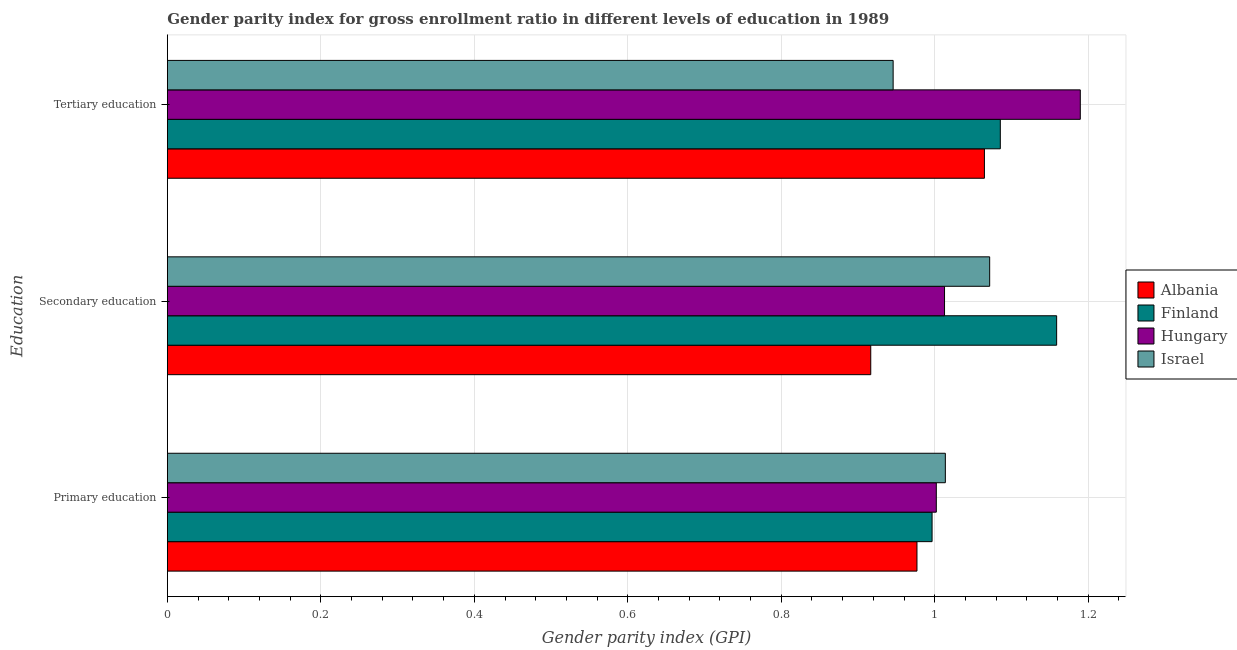How many groups of bars are there?
Provide a short and direct response. 3. Are the number of bars per tick equal to the number of legend labels?
Ensure brevity in your answer.  Yes. How many bars are there on the 1st tick from the top?
Keep it short and to the point. 4. What is the label of the 2nd group of bars from the top?
Give a very brief answer. Secondary education. What is the gender parity index in secondary education in Finland?
Your response must be concise. 1.16. Across all countries, what is the maximum gender parity index in tertiary education?
Keep it short and to the point. 1.19. Across all countries, what is the minimum gender parity index in secondary education?
Provide a succinct answer. 0.92. In which country was the gender parity index in tertiary education maximum?
Offer a very short reply. Hungary. In which country was the gender parity index in primary education minimum?
Give a very brief answer. Albania. What is the total gender parity index in primary education in the graph?
Your answer should be very brief. 3.99. What is the difference between the gender parity index in primary education in Israel and that in Albania?
Offer a very short reply. 0.04. What is the difference between the gender parity index in tertiary education in Finland and the gender parity index in primary education in Israel?
Make the answer very short. 0.07. What is the average gender parity index in secondary education per country?
Provide a short and direct response. 1.04. What is the difference between the gender parity index in primary education and gender parity index in secondary education in Israel?
Give a very brief answer. -0.06. In how many countries, is the gender parity index in tertiary education greater than 0.92 ?
Make the answer very short. 4. What is the ratio of the gender parity index in tertiary education in Israel to that in Finland?
Offer a very short reply. 0.87. Is the gender parity index in primary education in Albania less than that in Hungary?
Keep it short and to the point. Yes. Is the difference between the gender parity index in tertiary education in Israel and Albania greater than the difference between the gender parity index in secondary education in Israel and Albania?
Offer a very short reply. No. What is the difference between the highest and the second highest gender parity index in primary education?
Provide a succinct answer. 0.01. What is the difference between the highest and the lowest gender parity index in secondary education?
Provide a succinct answer. 0.24. What does the 2nd bar from the top in Primary education represents?
Give a very brief answer. Hungary. What does the 2nd bar from the bottom in Tertiary education represents?
Your answer should be compact. Finland. Does the graph contain any zero values?
Provide a succinct answer. No. Where does the legend appear in the graph?
Offer a terse response. Center right. How many legend labels are there?
Make the answer very short. 4. What is the title of the graph?
Provide a short and direct response. Gender parity index for gross enrollment ratio in different levels of education in 1989. What is the label or title of the X-axis?
Provide a succinct answer. Gender parity index (GPI). What is the label or title of the Y-axis?
Give a very brief answer. Education. What is the Gender parity index (GPI) in Albania in Primary education?
Keep it short and to the point. 0.98. What is the Gender parity index (GPI) in Finland in Primary education?
Provide a short and direct response. 1. What is the Gender parity index (GPI) of Hungary in Primary education?
Ensure brevity in your answer.  1. What is the Gender parity index (GPI) of Israel in Primary education?
Your response must be concise. 1.01. What is the Gender parity index (GPI) in Albania in Secondary education?
Keep it short and to the point. 0.92. What is the Gender parity index (GPI) of Finland in Secondary education?
Provide a short and direct response. 1.16. What is the Gender parity index (GPI) in Hungary in Secondary education?
Your response must be concise. 1.01. What is the Gender parity index (GPI) of Israel in Secondary education?
Keep it short and to the point. 1.07. What is the Gender parity index (GPI) of Albania in Tertiary education?
Make the answer very short. 1.06. What is the Gender parity index (GPI) in Finland in Tertiary education?
Give a very brief answer. 1.09. What is the Gender parity index (GPI) in Hungary in Tertiary education?
Your response must be concise. 1.19. What is the Gender parity index (GPI) of Israel in Tertiary education?
Make the answer very short. 0.95. Across all Education, what is the maximum Gender parity index (GPI) in Albania?
Your response must be concise. 1.06. Across all Education, what is the maximum Gender parity index (GPI) in Finland?
Your answer should be very brief. 1.16. Across all Education, what is the maximum Gender parity index (GPI) in Hungary?
Give a very brief answer. 1.19. Across all Education, what is the maximum Gender parity index (GPI) of Israel?
Offer a terse response. 1.07. Across all Education, what is the minimum Gender parity index (GPI) in Albania?
Offer a terse response. 0.92. Across all Education, what is the minimum Gender parity index (GPI) in Finland?
Keep it short and to the point. 1. Across all Education, what is the minimum Gender parity index (GPI) in Hungary?
Provide a succinct answer. 1. Across all Education, what is the minimum Gender parity index (GPI) of Israel?
Keep it short and to the point. 0.95. What is the total Gender parity index (GPI) in Albania in the graph?
Provide a succinct answer. 2.96. What is the total Gender parity index (GPI) of Finland in the graph?
Ensure brevity in your answer.  3.24. What is the total Gender parity index (GPI) in Hungary in the graph?
Ensure brevity in your answer.  3.2. What is the total Gender parity index (GPI) in Israel in the graph?
Provide a short and direct response. 3.03. What is the difference between the Gender parity index (GPI) in Albania in Primary education and that in Secondary education?
Give a very brief answer. 0.06. What is the difference between the Gender parity index (GPI) in Finland in Primary education and that in Secondary education?
Keep it short and to the point. -0.16. What is the difference between the Gender parity index (GPI) of Hungary in Primary education and that in Secondary education?
Offer a terse response. -0.01. What is the difference between the Gender parity index (GPI) in Israel in Primary education and that in Secondary education?
Give a very brief answer. -0.06. What is the difference between the Gender parity index (GPI) of Albania in Primary education and that in Tertiary education?
Your response must be concise. -0.09. What is the difference between the Gender parity index (GPI) in Finland in Primary education and that in Tertiary education?
Provide a short and direct response. -0.09. What is the difference between the Gender parity index (GPI) of Hungary in Primary education and that in Tertiary education?
Give a very brief answer. -0.19. What is the difference between the Gender parity index (GPI) of Israel in Primary education and that in Tertiary education?
Give a very brief answer. 0.07. What is the difference between the Gender parity index (GPI) in Albania in Secondary education and that in Tertiary education?
Your answer should be very brief. -0.15. What is the difference between the Gender parity index (GPI) of Finland in Secondary education and that in Tertiary education?
Provide a succinct answer. 0.07. What is the difference between the Gender parity index (GPI) of Hungary in Secondary education and that in Tertiary education?
Your answer should be very brief. -0.18. What is the difference between the Gender parity index (GPI) in Israel in Secondary education and that in Tertiary education?
Provide a succinct answer. 0.13. What is the difference between the Gender parity index (GPI) of Albania in Primary education and the Gender parity index (GPI) of Finland in Secondary education?
Keep it short and to the point. -0.18. What is the difference between the Gender parity index (GPI) in Albania in Primary education and the Gender parity index (GPI) in Hungary in Secondary education?
Keep it short and to the point. -0.04. What is the difference between the Gender parity index (GPI) in Albania in Primary education and the Gender parity index (GPI) in Israel in Secondary education?
Your answer should be very brief. -0.09. What is the difference between the Gender parity index (GPI) of Finland in Primary education and the Gender parity index (GPI) of Hungary in Secondary education?
Offer a very short reply. -0.02. What is the difference between the Gender parity index (GPI) of Finland in Primary education and the Gender parity index (GPI) of Israel in Secondary education?
Provide a short and direct response. -0.08. What is the difference between the Gender parity index (GPI) of Hungary in Primary education and the Gender parity index (GPI) of Israel in Secondary education?
Give a very brief answer. -0.07. What is the difference between the Gender parity index (GPI) of Albania in Primary education and the Gender parity index (GPI) of Finland in Tertiary education?
Keep it short and to the point. -0.11. What is the difference between the Gender parity index (GPI) in Albania in Primary education and the Gender parity index (GPI) in Hungary in Tertiary education?
Your answer should be compact. -0.21. What is the difference between the Gender parity index (GPI) in Albania in Primary education and the Gender parity index (GPI) in Israel in Tertiary education?
Provide a succinct answer. 0.03. What is the difference between the Gender parity index (GPI) of Finland in Primary education and the Gender parity index (GPI) of Hungary in Tertiary education?
Offer a terse response. -0.19. What is the difference between the Gender parity index (GPI) in Finland in Primary education and the Gender parity index (GPI) in Israel in Tertiary education?
Your response must be concise. 0.05. What is the difference between the Gender parity index (GPI) of Hungary in Primary education and the Gender parity index (GPI) of Israel in Tertiary education?
Offer a terse response. 0.06. What is the difference between the Gender parity index (GPI) of Albania in Secondary education and the Gender parity index (GPI) of Finland in Tertiary education?
Give a very brief answer. -0.17. What is the difference between the Gender parity index (GPI) in Albania in Secondary education and the Gender parity index (GPI) in Hungary in Tertiary education?
Your answer should be compact. -0.27. What is the difference between the Gender parity index (GPI) of Albania in Secondary education and the Gender parity index (GPI) of Israel in Tertiary education?
Make the answer very short. -0.03. What is the difference between the Gender parity index (GPI) of Finland in Secondary education and the Gender parity index (GPI) of Hungary in Tertiary education?
Provide a short and direct response. -0.03. What is the difference between the Gender parity index (GPI) of Finland in Secondary education and the Gender parity index (GPI) of Israel in Tertiary education?
Offer a very short reply. 0.21. What is the difference between the Gender parity index (GPI) in Hungary in Secondary education and the Gender parity index (GPI) in Israel in Tertiary education?
Offer a very short reply. 0.07. What is the average Gender parity index (GPI) of Albania per Education?
Provide a succinct answer. 0.99. What is the average Gender parity index (GPI) of Finland per Education?
Make the answer very short. 1.08. What is the average Gender parity index (GPI) of Hungary per Education?
Give a very brief answer. 1.07. What is the average Gender parity index (GPI) in Israel per Education?
Give a very brief answer. 1.01. What is the difference between the Gender parity index (GPI) of Albania and Gender parity index (GPI) of Finland in Primary education?
Offer a very short reply. -0.02. What is the difference between the Gender parity index (GPI) in Albania and Gender parity index (GPI) in Hungary in Primary education?
Your answer should be compact. -0.03. What is the difference between the Gender parity index (GPI) in Albania and Gender parity index (GPI) in Israel in Primary education?
Your answer should be very brief. -0.04. What is the difference between the Gender parity index (GPI) in Finland and Gender parity index (GPI) in Hungary in Primary education?
Your answer should be very brief. -0.01. What is the difference between the Gender parity index (GPI) in Finland and Gender parity index (GPI) in Israel in Primary education?
Your answer should be very brief. -0.02. What is the difference between the Gender parity index (GPI) of Hungary and Gender parity index (GPI) of Israel in Primary education?
Offer a very short reply. -0.01. What is the difference between the Gender parity index (GPI) in Albania and Gender parity index (GPI) in Finland in Secondary education?
Your answer should be compact. -0.24. What is the difference between the Gender parity index (GPI) in Albania and Gender parity index (GPI) in Hungary in Secondary education?
Your answer should be compact. -0.1. What is the difference between the Gender parity index (GPI) of Albania and Gender parity index (GPI) of Israel in Secondary education?
Your response must be concise. -0.15. What is the difference between the Gender parity index (GPI) in Finland and Gender parity index (GPI) in Hungary in Secondary education?
Offer a very short reply. 0.15. What is the difference between the Gender parity index (GPI) of Finland and Gender parity index (GPI) of Israel in Secondary education?
Provide a short and direct response. 0.09. What is the difference between the Gender parity index (GPI) in Hungary and Gender parity index (GPI) in Israel in Secondary education?
Your response must be concise. -0.06. What is the difference between the Gender parity index (GPI) of Albania and Gender parity index (GPI) of Finland in Tertiary education?
Give a very brief answer. -0.02. What is the difference between the Gender parity index (GPI) of Albania and Gender parity index (GPI) of Hungary in Tertiary education?
Ensure brevity in your answer.  -0.12. What is the difference between the Gender parity index (GPI) in Albania and Gender parity index (GPI) in Israel in Tertiary education?
Your response must be concise. 0.12. What is the difference between the Gender parity index (GPI) in Finland and Gender parity index (GPI) in Hungary in Tertiary education?
Keep it short and to the point. -0.1. What is the difference between the Gender parity index (GPI) in Finland and Gender parity index (GPI) in Israel in Tertiary education?
Your answer should be very brief. 0.14. What is the difference between the Gender parity index (GPI) of Hungary and Gender parity index (GPI) of Israel in Tertiary education?
Keep it short and to the point. 0.24. What is the ratio of the Gender parity index (GPI) of Albania in Primary education to that in Secondary education?
Provide a short and direct response. 1.07. What is the ratio of the Gender parity index (GPI) in Finland in Primary education to that in Secondary education?
Make the answer very short. 0.86. What is the ratio of the Gender parity index (GPI) in Israel in Primary education to that in Secondary education?
Give a very brief answer. 0.95. What is the ratio of the Gender parity index (GPI) of Albania in Primary education to that in Tertiary education?
Offer a very short reply. 0.92. What is the ratio of the Gender parity index (GPI) of Finland in Primary education to that in Tertiary education?
Offer a very short reply. 0.92. What is the ratio of the Gender parity index (GPI) in Hungary in Primary education to that in Tertiary education?
Ensure brevity in your answer.  0.84. What is the ratio of the Gender parity index (GPI) in Israel in Primary education to that in Tertiary education?
Make the answer very short. 1.07. What is the ratio of the Gender parity index (GPI) of Albania in Secondary education to that in Tertiary education?
Ensure brevity in your answer.  0.86. What is the ratio of the Gender parity index (GPI) in Finland in Secondary education to that in Tertiary education?
Give a very brief answer. 1.07. What is the ratio of the Gender parity index (GPI) of Hungary in Secondary education to that in Tertiary education?
Give a very brief answer. 0.85. What is the ratio of the Gender parity index (GPI) in Israel in Secondary education to that in Tertiary education?
Offer a terse response. 1.13. What is the difference between the highest and the second highest Gender parity index (GPI) in Albania?
Offer a very short reply. 0.09. What is the difference between the highest and the second highest Gender parity index (GPI) of Finland?
Your response must be concise. 0.07. What is the difference between the highest and the second highest Gender parity index (GPI) of Hungary?
Provide a short and direct response. 0.18. What is the difference between the highest and the second highest Gender parity index (GPI) of Israel?
Your answer should be compact. 0.06. What is the difference between the highest and the lowest Gender parity index (GPI) of Albania?
Provide a succinct answer. 0.15. What is the difference between the highest and the lowest Gender parity index (GPI) of Finland?
Keep it short and to the point. 0.16. What is the difference between the highest and the lowest Gender parity index (GPI) of Hungary?
Offer a very short reply. 0.19. What is the difference between the highest and the lowest Gender parity index (GPI) of Israel?
Your answer should be very brief. 0.13. 